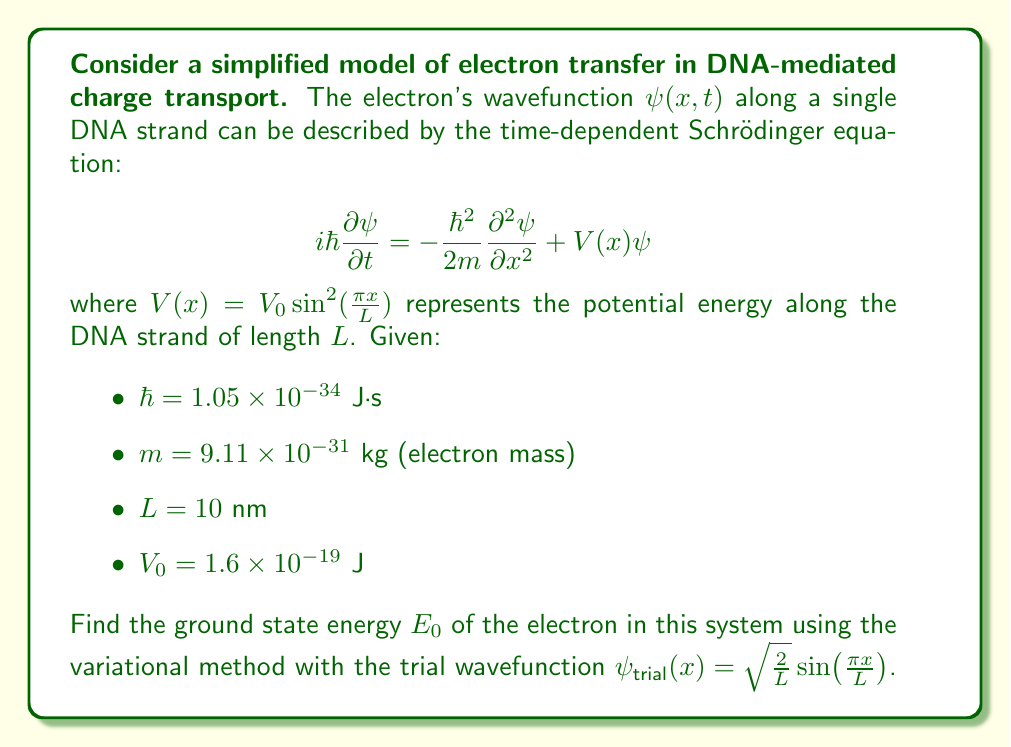Help me with this question. To solve this problem, we'll use the variational method to estimate the ground state energy. The steps are as follows:

1) The variational method states that for any normalized trial wavefunction $\psi_{\text{trial}}$, the expectation value of the Hamiltonian is an upper bound to the true ground state energy:

   $$E_0 \leq \langle \psi_{\text{trial}}|\hat{H}|\psi_{\text{trial}} \rangle$$

2) The Hamiltonian $\hat{H}$ is given by:

   $$\hat{H} = -\frac{\hbar^2}{2m} \frac{\partial^2}{\partial x^2} + V_0 \sin^2(\frac{\pi x}{L})$$

3) We need to calculate $\langle \psi_{\text{trial}}|\hat{H}|\psi_{\text{trial}} \rangle$:

   $$\langle \psi_{\text{trial}}|\hat{H}|\psi_{\text{trial}} \rangle = \int_0^L \psi_{\text{trial}}^*(x) \hat{H} \psi_{\text{trial}}(x) dx$$

4) Let's calculate this integral term by term:

   a) Kinetic energy term:
      $$-\frac{\hbar^2}{2m} \int_0^L \psi_{\text{trial}}^*(x) \frac{\partial^2}{\partial x^2} \psi_{\text{trial}}(x) dx$$
      $$= \frac{\hbar^2}{2m} (\frac{\pi}{L})^2 \int_0^L \frac{2}{L} \sin^2(\frac{\pi x}{L}) dx = \frac{\hbar^2 \pi^2}{2mL^2}$$

   b) Potential energy term:
      $$V_0 \int_0^L \psi_{\text{trial}}^*(x) \sin^2(\frac{\pi x}{L}) \psi_{\text{trial}}(x) dx$$
      $$= \frac{2V_0}{L} \int_0^L \sin^2(\frac{\pi x}{L}) \sin^2(\frac{\pi x}{L}) dx = \frac{3V_0}{4}$$

5) Adding these terms:

   $$E_0 \leq \frac{\hbar^2 \pi^2}{2mL^2} + \frac{3V_0}{4}$$

6) Now, let's substitute the given values:

   $$E_0 \leq \frac{(1.05 \times 10^{-34})^2 \pi^2}{2(9.11 \times 10^{-31})(10 \times 10^{-9})^2} + \frac{3(1.6 \times 10^{-19})}{4}$$

7) Calculating this:

   $$E_0 \leq 6.17 \times 10^{-20} + 1.2 \times 10^{-19} = 1.82 \times 10^{-19} \text{ J}$$

Therefore, the upper bound for the ground state energy is $1.82 \times 10^{-19}$ J.
Answer: $E_0 \leq 1.82 \times 10^{-19}$ J 